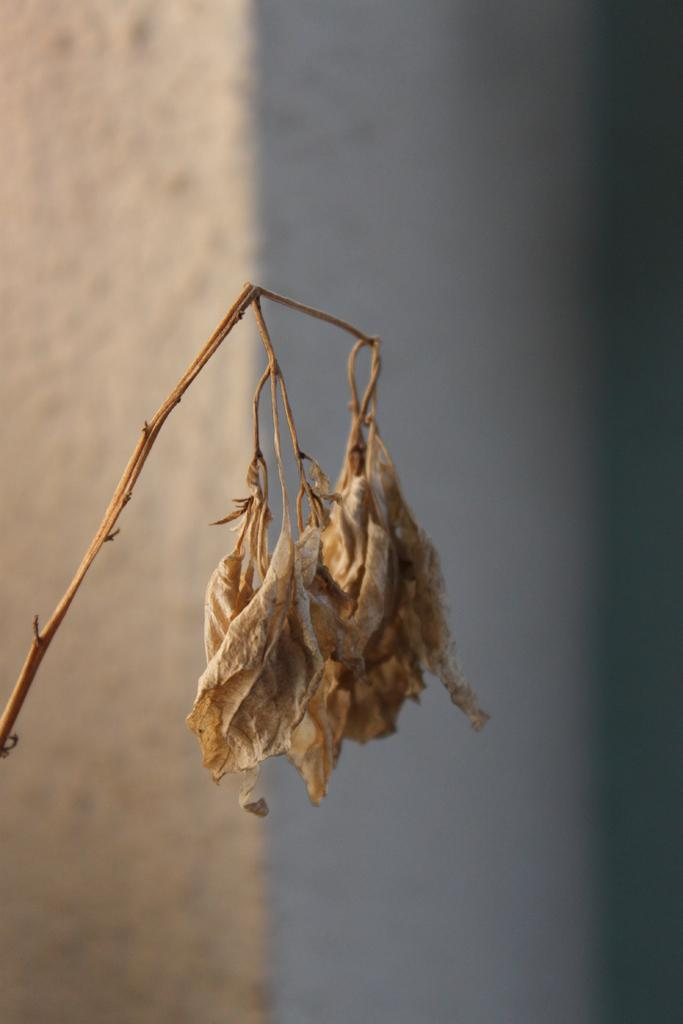What type of plant can be seen in the image? There is a dried small plant with flowers in the image. What is visible in the background of the image? There is a wall in the background of the image. What color is the wall in the image? The wall is white in color. What type of net is being used to catch the toothbrush in the image? There is no net or toothbrush present in the image. How is the kite being used in the image? There is no kite present in the image. 